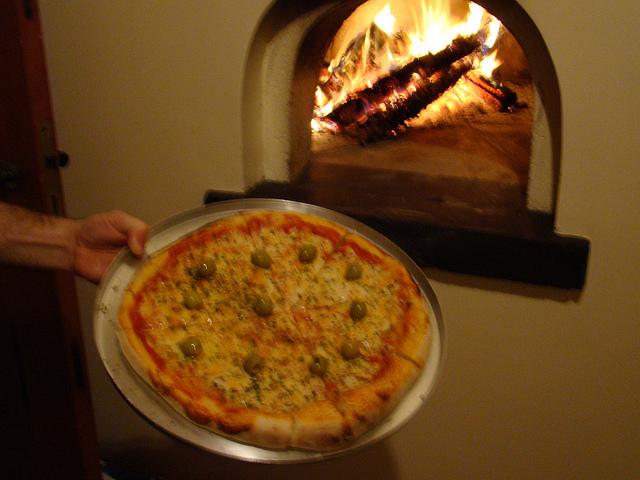Does the pizza have olives on it?
Answer briefly. Yes. Is the pan hot?
Answer briefly. No. How many pieces of pizza are shown?
Short answer required. 8. 